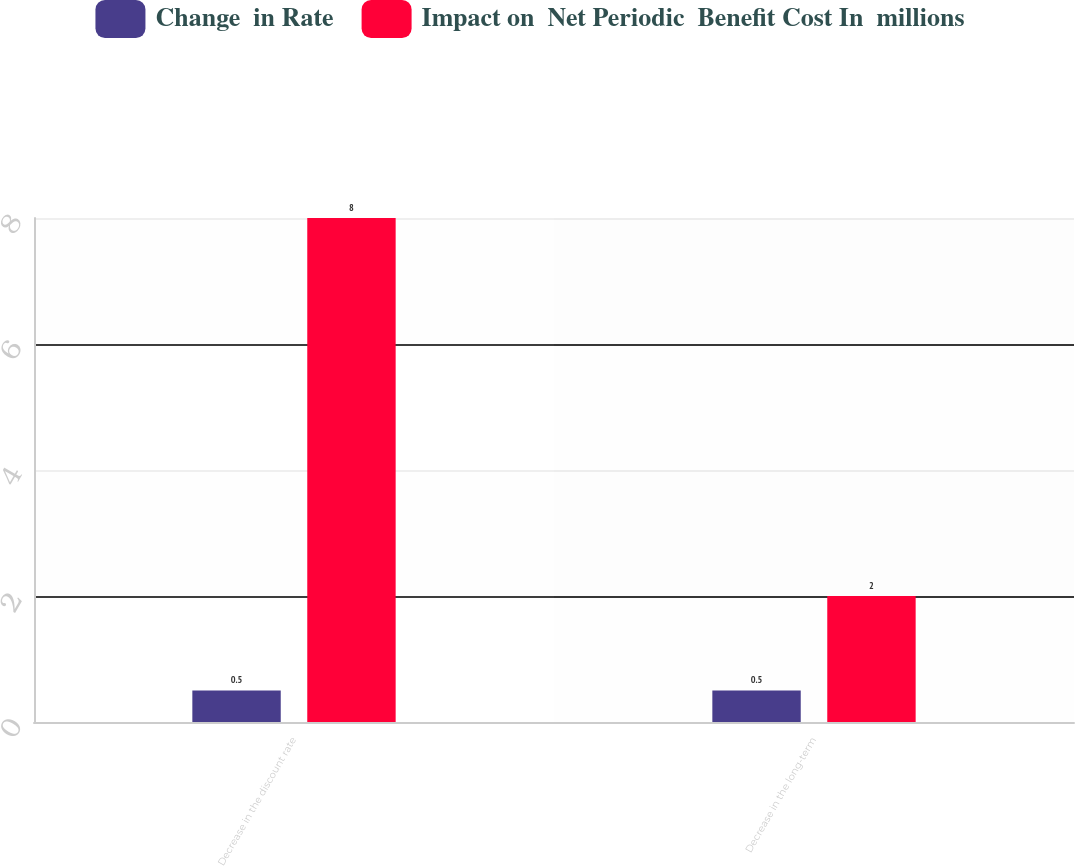<chart> <loc_0><loc_0><loc_500><loc_500><stacked_bar_chart><ecel><fcel>Decrease in the discount rate<fcel>Decrease in the long-term<nl><fcel>Change  in Rate<fcel>0.5<fcel>0.5<nl><fcel>Impact on  Net Periodic  Benefit Cost In  millions<fcel>8<fcel>2<nl></chart> 